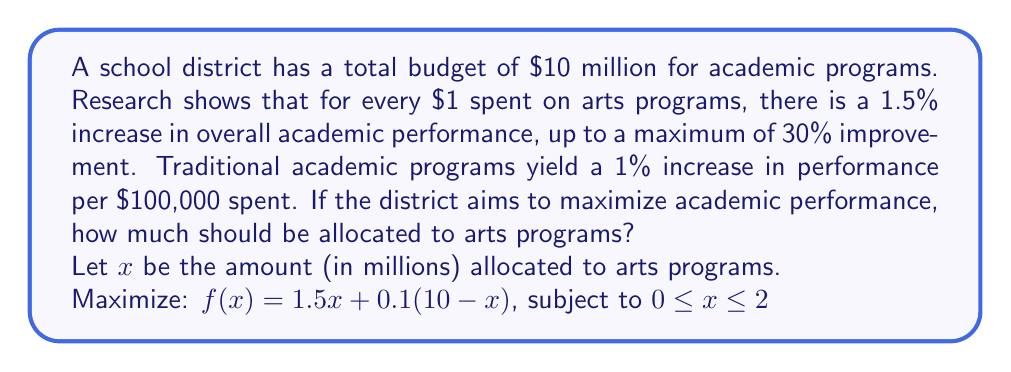What is the answer to this math problem? 1) The function $f(x)$ represents the total performance increase:
   - Arts contribution: $1.5x$ (1.5% per $1 million, up to 30%)
   - Traditional academics contribution: $0.1(10-x)$ (1% per $100,000)

2) To find the maximum, we need to consider three cases:
   a) The maximum occurs at $x = 0$
   b) The maximum occurs at $x = 2$ (since 30% is the cap for arts improvement)
   c) The maximum occurs at a critical point within the interval

3) Let's find the critical point by taking the derivative:
   $f'(x) = 1.5 - 0.1 = 1.4$

4) Since $f'(x)$ is constant and positive, the function is always increasing.

5) Therefore, the maximum will occur at the upper bound of the interval, $x = 2$.

6) Verify:
   $f(0) = 0 + 0.1(10) = 1$
   $f(2) = 1.5(2) + 0.1(8) = 3.8$

7) The maximum performance increase is achieved when $2 million is allocated to arts programs.
Answer: $2 million 